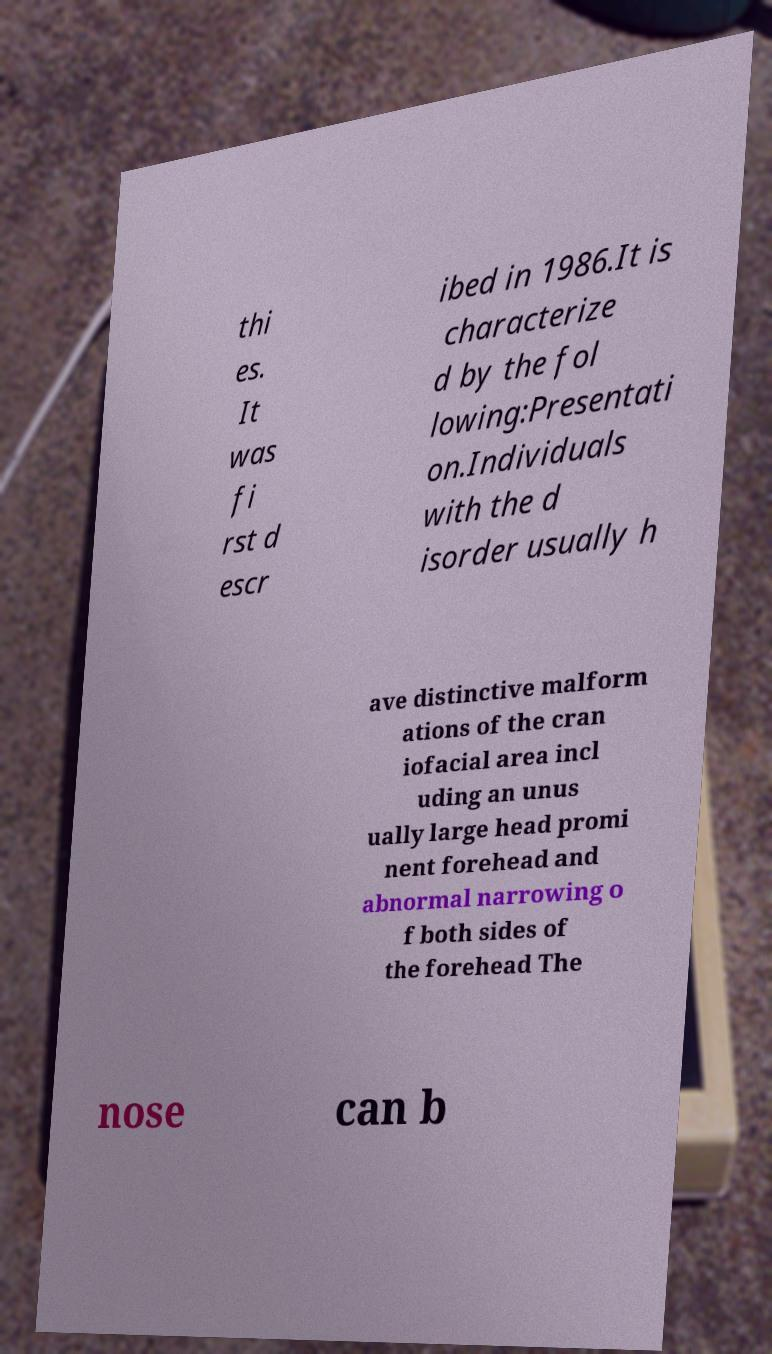Can you read and provide the text displayed in the image?This photo seems to have some interesting text. Can you extract and type it out for me? thi es. It was fi rst d escr ibed in 1986.It is characterize d by the fol lowing:Presentati on.Individuals with the d isorder usually h ave distinctive malform ations of the cran iofacial area incl uding an unus ually large head promi nent forehead and abnormal narrowing o f both sides of the forehead The nose can b 